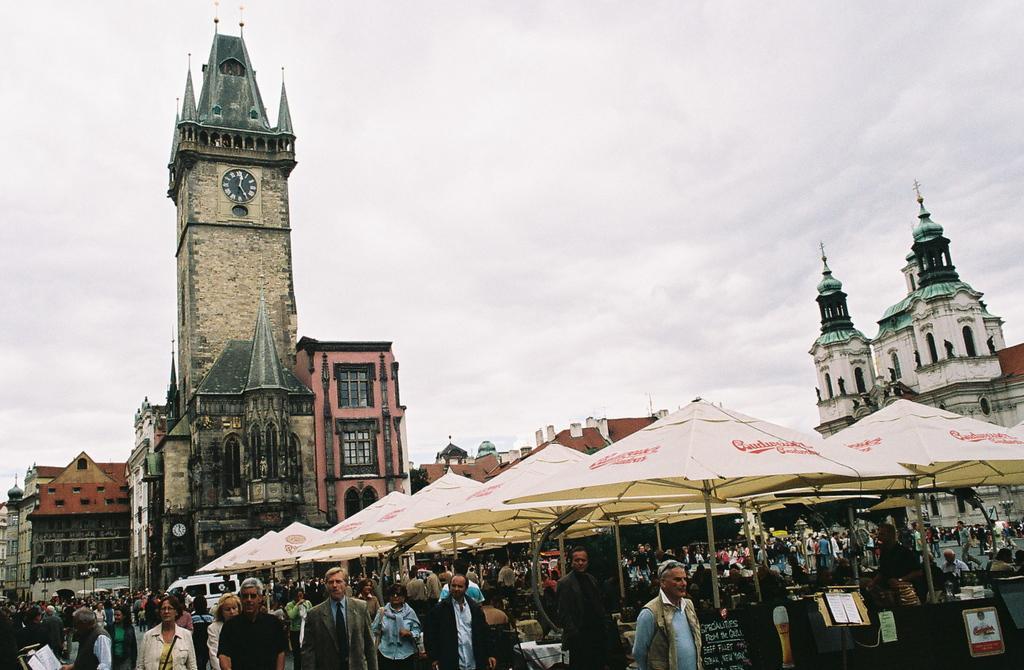Can you describe this image briefly? In this picture we can see a group of people standing, umbrellas, boards, buildings with windows, clock and in the background we can see the sky with clouds. 